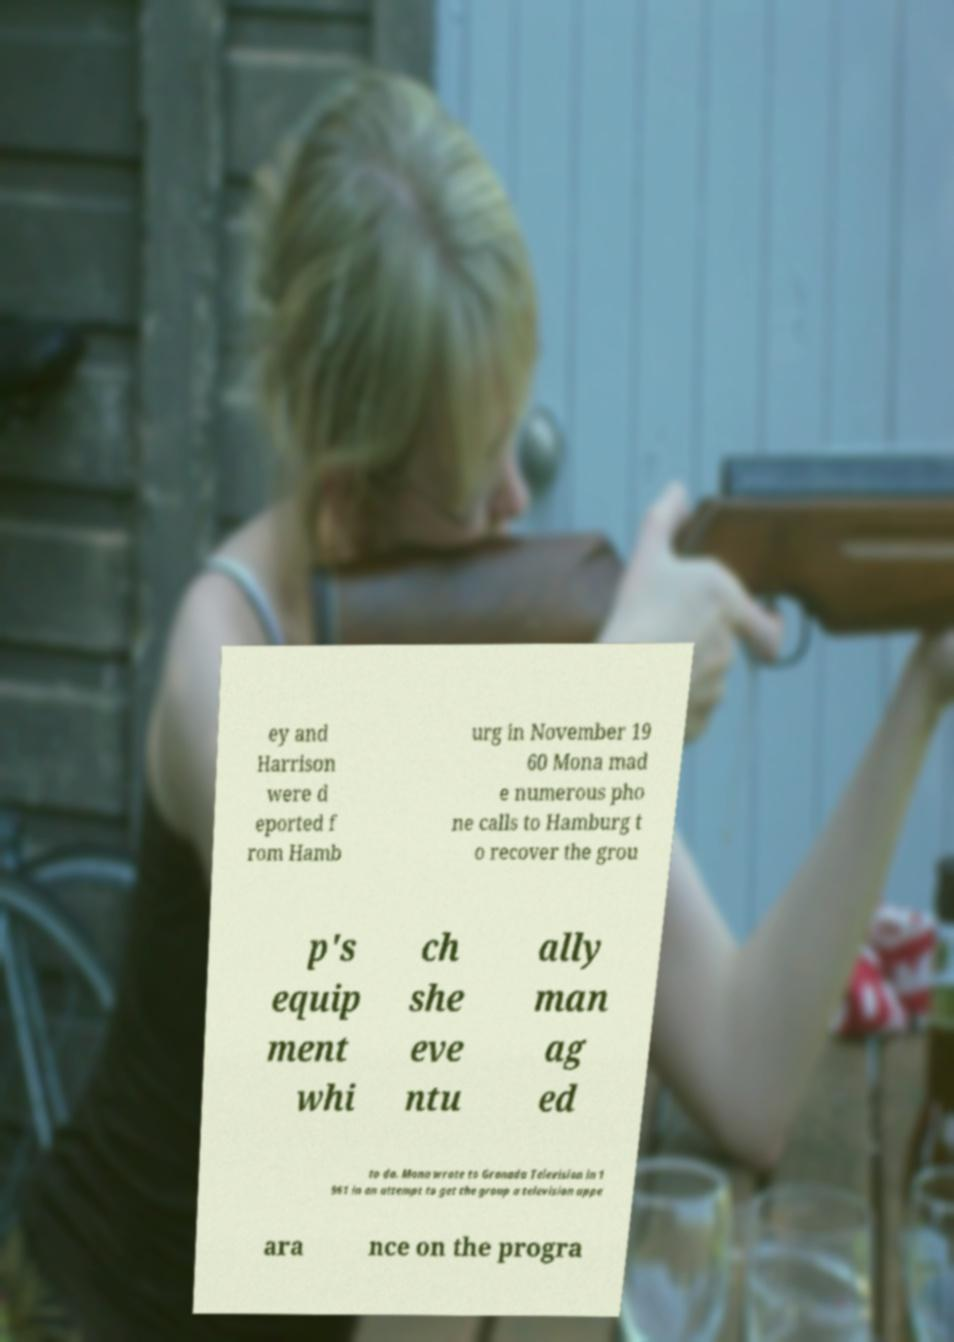I need the written content from this picture converted into text. Can you do that? ey and Harrison were d eported f rom Hamb urg in November 19 60 Mona mad e numerous pho ne calls to Hamburg t o recover the grou p's equip ment whi ch she eve ntu ally man ag ed to do. Mona wrote to Granada Television in 1 961 in an attempt to get the group a television appe ara nce on the progra 